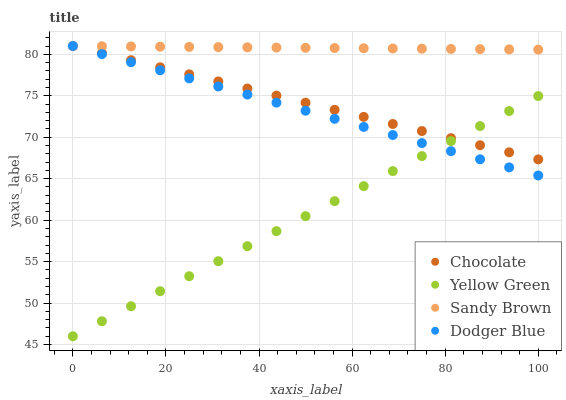Does Yellow Green have the minimum area under the curve?
Answer yes or no. Yes. Does Sandy Brown have the maximum area under the curve?
Answer yes or no. Yes. Does Sandy Brown have the minimum area under the curve?
Answer yes or no. No. Does Yellow Green have the maximum area under the curve?
Answer yes or no. No. Is Sandy Brown the smoothest?
Answer yes or no. Yes. Is Chocolate the roughest?
Answer yes or no. Yes. Is Yellow Green the smoothest?
Answer yes or no. No. Is Yellow Green the roughest?
Answer yes or no. No. Does Yellow Green have the lowest value?
Answer yes or no. Yes. Does Sandy Brown have the lowest value?
Answer yes or no. No. Does Chocolate have the highest value?
Answer yes or no. Yes. Does Yellow Green have the highest value?
Answer yes or no. No. Is Yellow Green less than Sandy Brown?
Answer yes or no. Yes. Is Sandy Brown greater than Yellow Green?
Answer yes or no. Yes. Does Chocolate intersect Sandy Brown?
Answer yes or no. Yes. Is Chocolate less than Sandy Brown?
Answer yes or no. No. Is Chocolate greater than Sandy Brown?
Answer yes or no. No. Does Yellow Green intersect Sandy Brown?
Answer yes or no. No. 